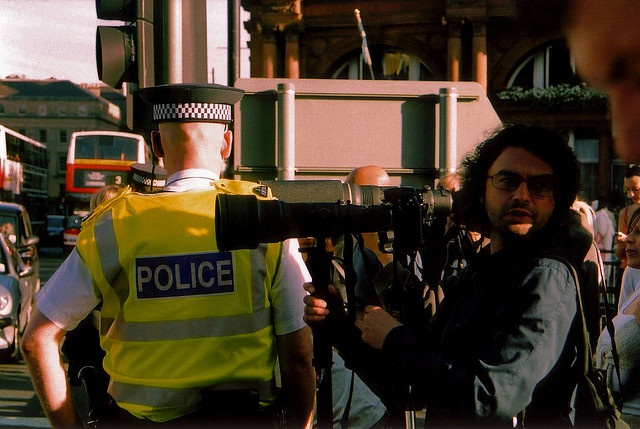Describe the objects in this image and their specific colors. I can see people in lightgray, black, olive, and gray tones, people in lightgray, black, gray, and maroon tones, people in lightgray, maroon, black, and gray tones, backpack in lightgray, black, gray, and darkgreen tones, and people in lightgray, black, gray, and maroon tones in this image. 